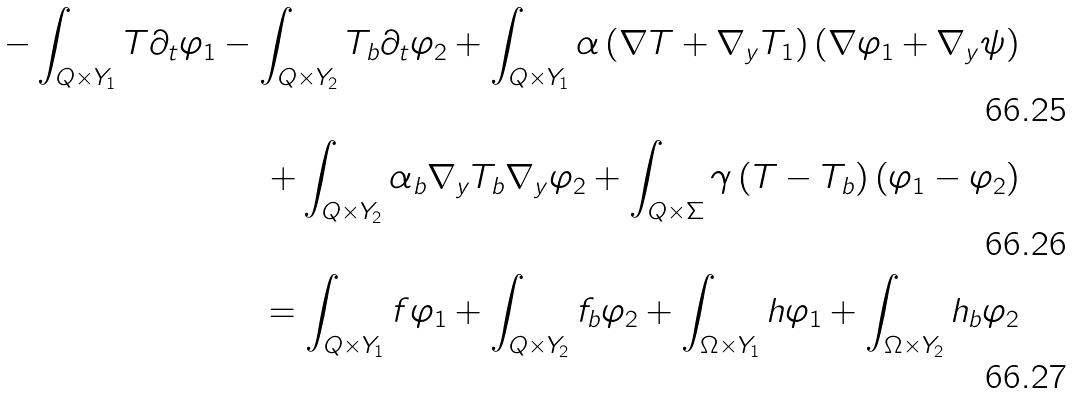<formula> <loc_0><loc_0><loc_500><loc_500>- \int _ { Q \times Y _ { 1 } } T \partial _ { t } \varphi _ { 1 } - \int _ { Q \times Y _ { 2 } } T _ { b } \partial _ { t } \varphi _ { 2 } + \int _ { Q \times Y _ { 1 } } \alpha \left ( \nabla T + \nabla _ { y } T _ { 1 } \right ) \left ( \nabla \varphi _ { 1 } + \nabla _ { y } \psi \right ) \\ + \int _ { Q \times Y _ { 2 } } \alpha _ { b } \nabla _ { y } T _ { b } \nabla _ { y } \varphi _ { 2 } + \int _ { Q \times \Sigma } \gamma \left ( T - T _ { b } \right ) \left ( \varphi _ { 1 } - \varphi _ { 2 } \right ) \\ = \int _ { Q \times Y _ { 1 } } f \varphi _ { 1 } + \int _ { Q \times Y _ { 2 } } f _ { b } \varphi _ { 2 } + \int _ { \Omega \times Y _ { 1 } } h \varphi _ { 1 } + \int _ { \Omega \times Y _ { 2 } } h _ { b } \varphi _ { 2 }</formula> 